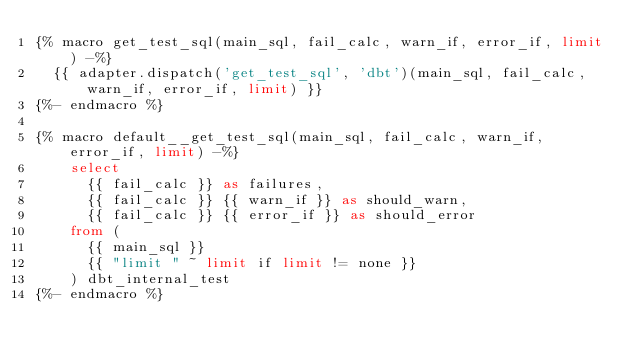<code> <loc_0><loc_0><loc_500><loc_500><_SQL_>{% macro get_test_sql(main_sql, fail_calc, warn_if, error_if, limit) -%}
  {{ adapter.dispatch('get_test_sql', 'dbt')(main_sql, fail_calc, warn_if, error_if, limit) }}
{%- endmacro %}

{% macro default__get_test_sql(main_sql, fail_calc, warn_if, error_if, limit) -%}
    select
      {{ fail_calc }} as failures,
      {{ fail_calc }} {{ warn_if }} as should_warn,
      {{ fail_calc }} {{ error_if }} as should_error
    from (
      {{ main_sql }}
      {{ "limit " ~ limit if limit != none }}
    ) dbt_internal_test
{%- endmacro %}
</code> 